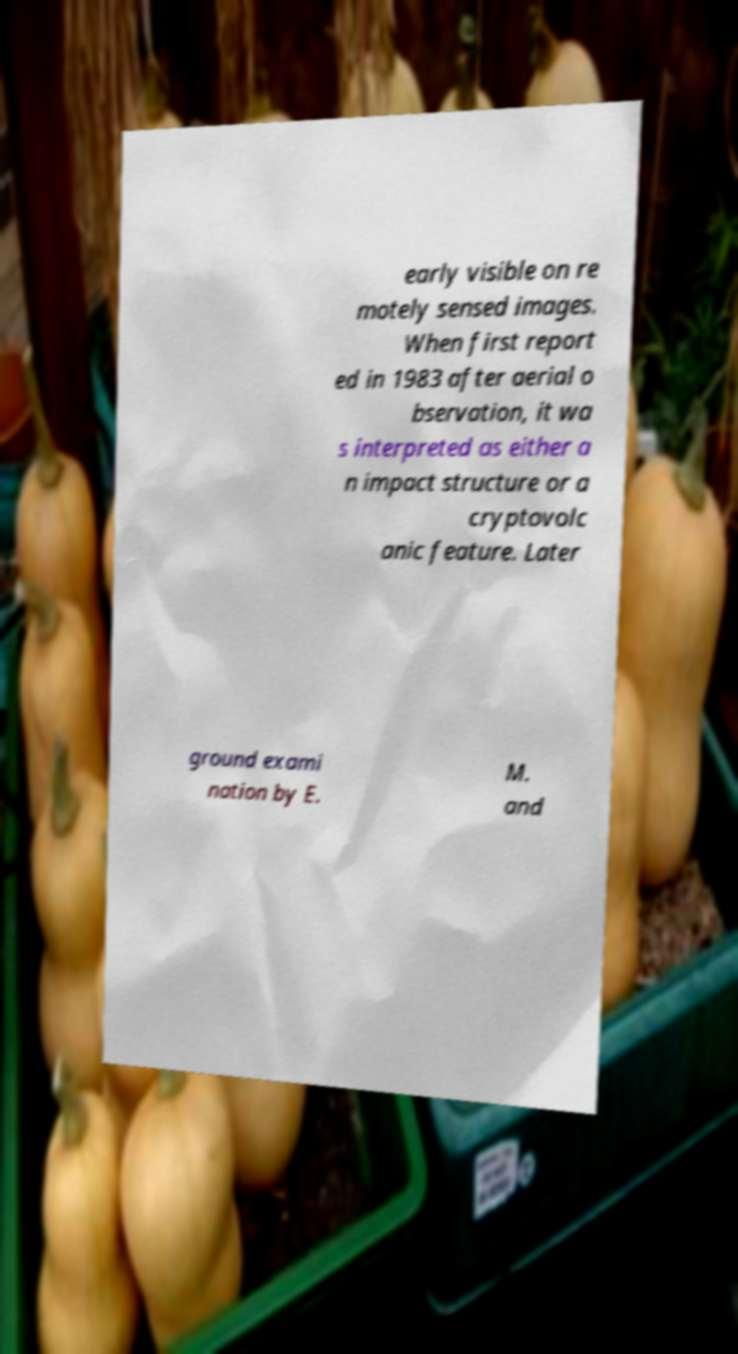What messages or text are displayed in this image? I need them in a readable, typed format. early visible on re motely sensed images. When first report ed in 1983 after aerial o bservation, it wa s interpreted as either a n impact structure or a cryptovolc anic feature. Later ground exami nation by E. M. and 